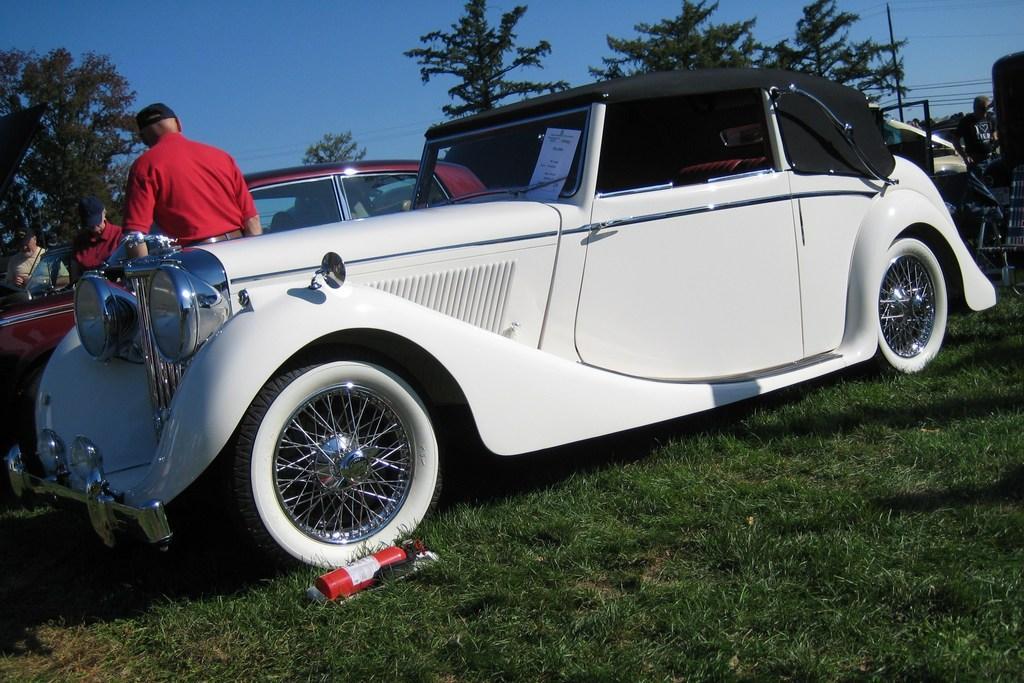Could you give a brief overview of what you see in this image? In this picture, we can see a few vehicles, people, and we can see the ground, and we can see red color object on the ground, and we can see the ground covered with grass, trees, poles, wires and the sky. 